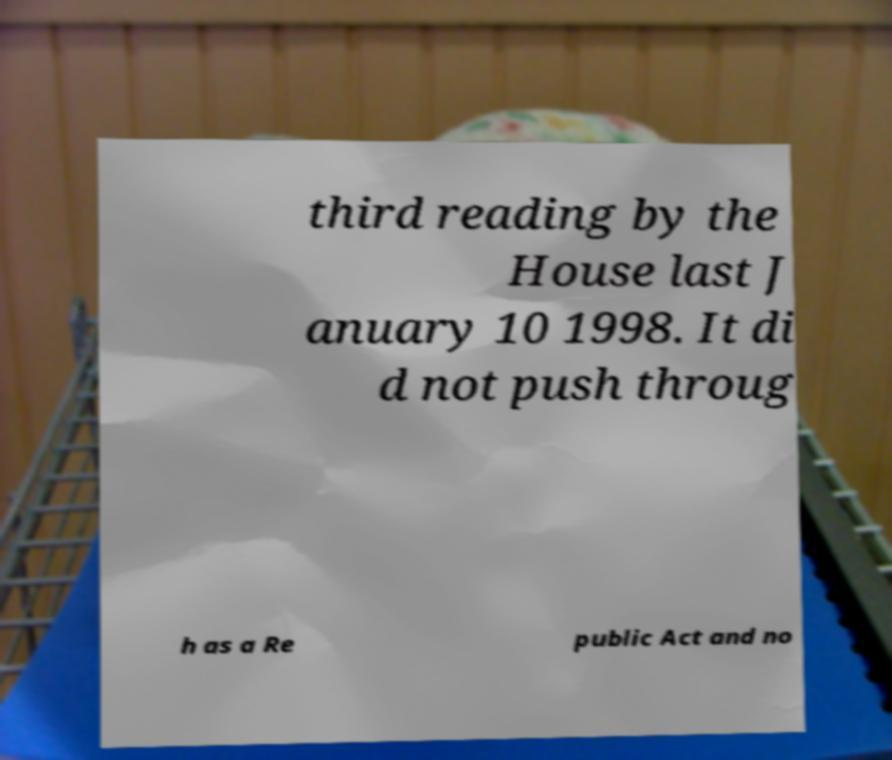Please read and relay the text visible in this image. What does it say? third reading by the House last J anuary 10 1998. It di d not push throug h as a Re public Act and no 